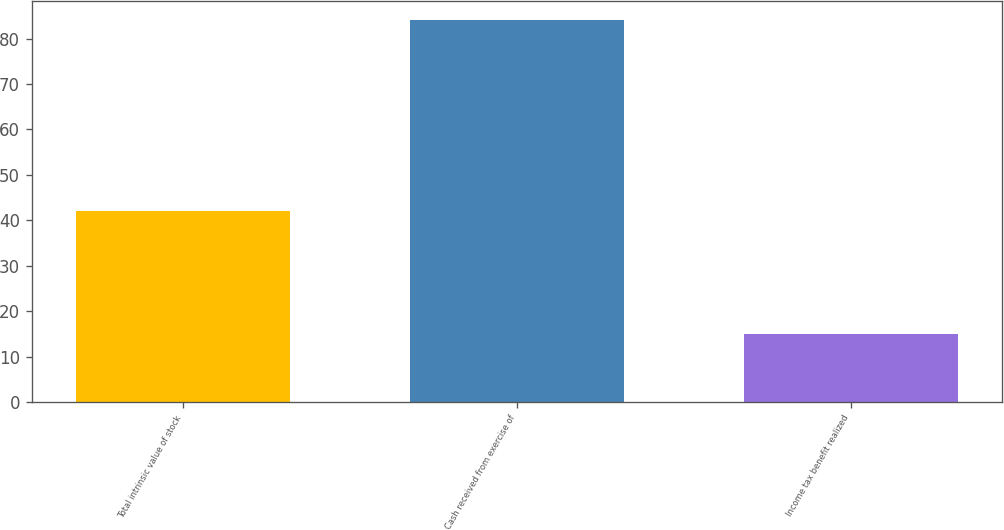Convert chart. <chart><loc_0><loc_0><loc_500><loc_500><bar_chart><fcel>Total intrinsic value of stock<fcel>Cash received from exercise of<fcel>Income tax benefit realized<nl><fcel>42<fcel>84<fcel>15<nl></chart> 